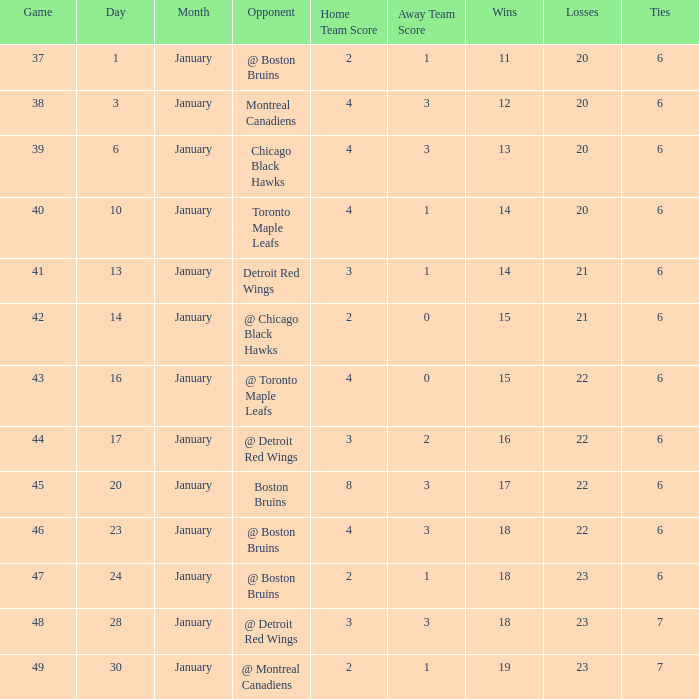Who was the opponent with the record of 15-21-6? @ Chicago Black Hawks. 